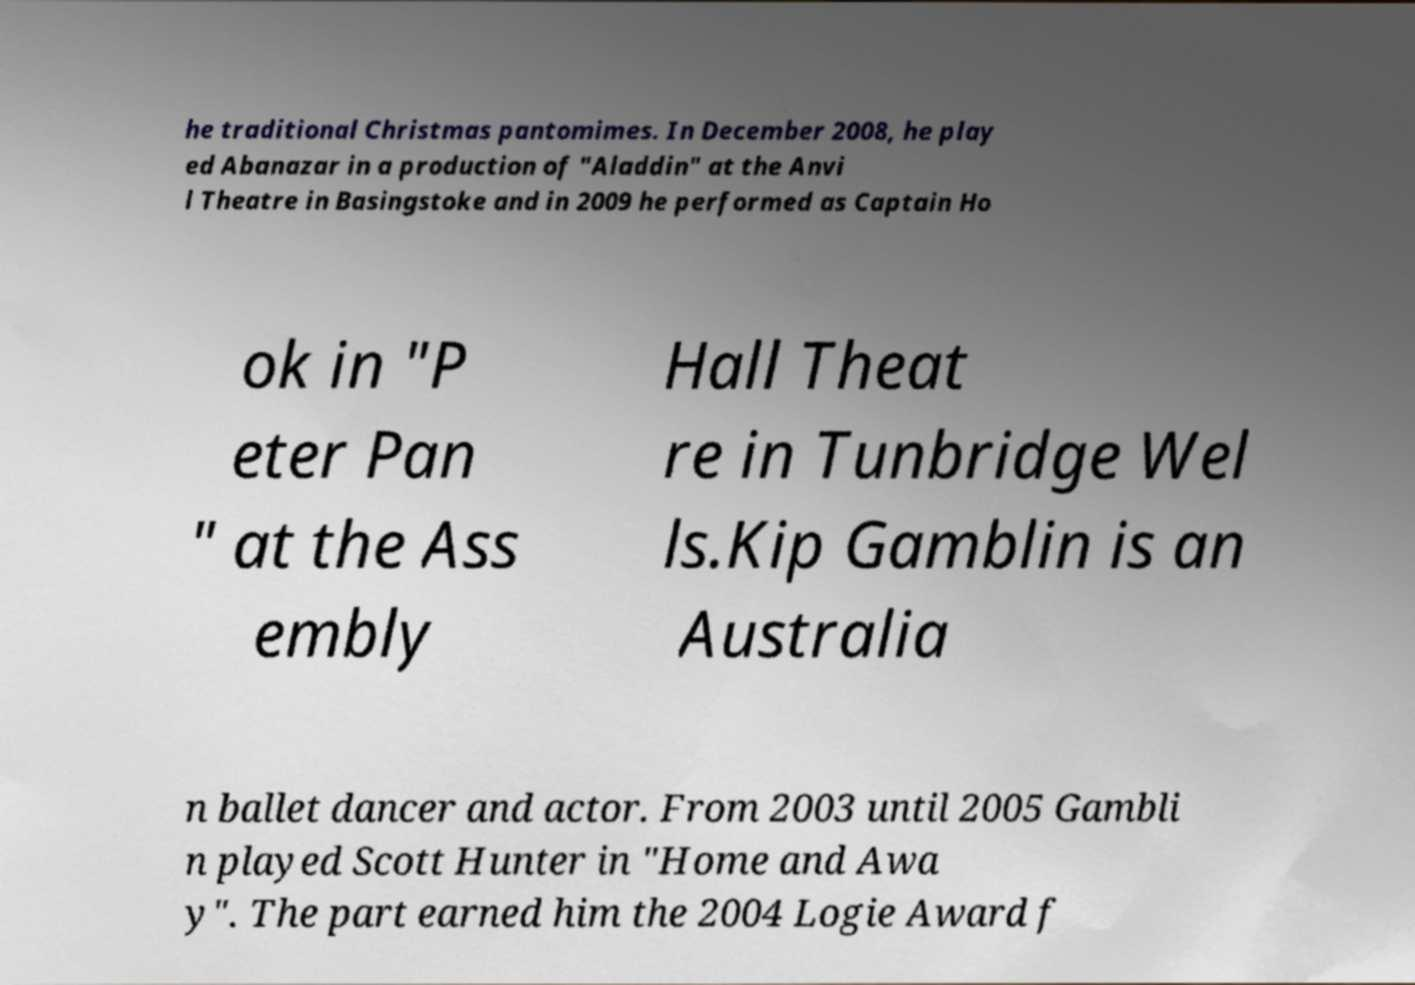Can you accurately transcribe the text from the provided image for me? he traditional Christmas pantomimes. In December 2008, he play ed Abanazar in a production of "Aladdin" at the Anvi l Theatre in Basingstoke and in 2009 he performed as Captain Ho ok in "P eter Pan " at the Ass embly Hall Theat re in Tunbridge Wel ls.Kip Gamblin is an Australia n ballet dancer and actor. From 2003 until 2005 Gambli n played Scott Hunter in "Home and Awa y". The part earned him the 2004 Logie Award f 